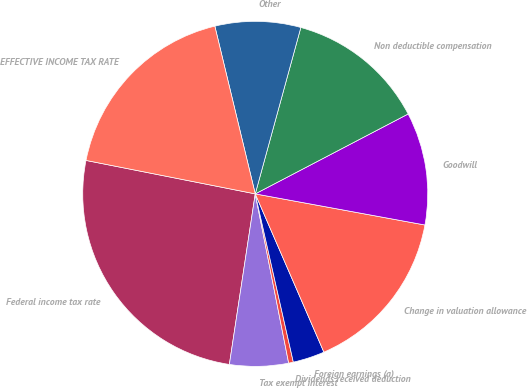<chart> <loc_0><loc_0><loc_500><loc_500><pie_chart><fcel>Federal income tax rate<fcel>Tax exempt interest<fcel>Dividends received deduction<fcel>Foreign earnings (a)<fcel>Change in valuation allowance<fcel>Goodwill<fcel>Non deductible compensation<fcel>Other<fcel>EFFECTIVE INCOME TAX RATE<nl><fcel>25.71%<fcel>5.5%<fcel>0.44%<fcel>2.97%<fcel>15.6%<fcel>10.55%<fcel>13.08%<fcel>8.02%<fcel>18.13%<nl></chart> 